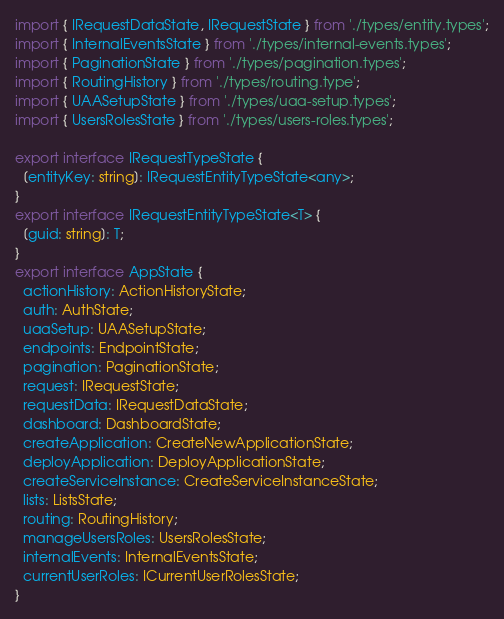<code> <loc_0><loc_0><loc_500><loc_500><_TypeScript_>import { IRequestDataState, IRequestState } from './types/entity.types';
import { InternalEventsState } from './types/internal-events.types';
import { PaginationState } from './types/pagination.types';
import { RoutingHistory } from './types/routing.type';
import { UAASetupState } from './types/uaa-setup.types';
import { UsersRolesState } from './types/users-roles.types';

export interface IRequestTypeState {
  [entityKey: string]: IRequestEntityTypeState<any>;
}
export interface IRequestEntityTypeState<T> {
  [guid: string]: T;
}
export interface AppState {
  actionHistory: ActionHistoryState;
  auth: AuthState;
  uaaSetup: UAASetupState;
  endpoints: EndpointState;
  pagination: PaginationState;
  request: IRequestState;
  requestData: IRequestDataState;
  dashboard: DashboardState;
  createApplication: CreateNewApplicationState;
  deployApplication: DeployApplicationState;
  createServiceInstance: CreateServiceInstanceState;
  lists: ListsState;
  routing: RoutingHistory;
  manageUsersRoles: UsersRolesState;
  internalEvents: InternalEventsState;
  currentUserRoles: ICurrentUserRolesState;
}
</code> 